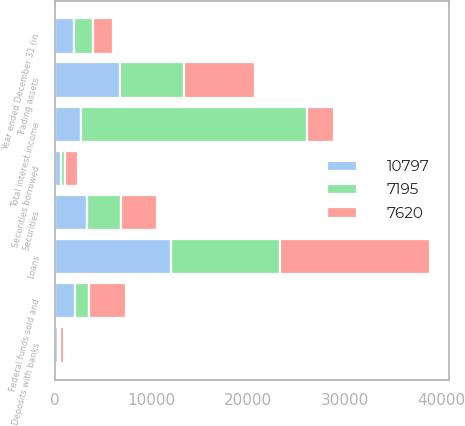Convert chart. <chart><loc_0><loc_0><loc_500><loc_500><stacked_bar_chart><ecel><fcel>Year ended December 31 (in<fcel>Loans<fcel>Securities<fcel>Trading assets<fcel>Federal funds sold and<fcel>Securities borrowed<fcel>Deposits with banks<fcel>Total interest income<nl><fcel>7195<fcel>2003<fcel>11276<fcel>3542<fcel>6592<fcel>1497<fcel>323<fcel>214<fcel>23444<nl><fcel>10797<fcel>2002<fcel>12057<fcel>3367<fcel>6798<fcel>2061<fcel>698<fcel>303<fcel>2714<nl><fcel>7620<fcel>2001<fcel>15544<fcel>3647<fcel>7390<fcel>3805<fcel>1343<fcel>452<fcel>2714<nl></chart> 